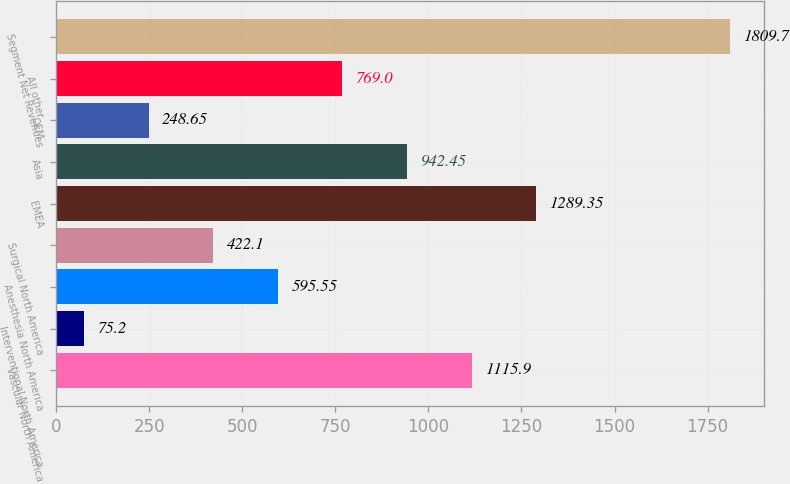<chart> <loc_0><loc_0><loc_500><loc_500><bar_chart><fcel>Vascular North America<fcel>Interventional North America<fcel>Anesthesia North America<fcel>Surgical North America<fcel>EMEA<fcel>Asia<fcel>OEM<fcel>All other<fcel>Segment Net Revenues<nl><fcel>1115.9<fcel>75.2<fcel>595.55<fcel>422.1<fcel>1289.35<fcel>942.45<fcel>248.65<fcel>769<fcel>1809.7<nl></chart> 